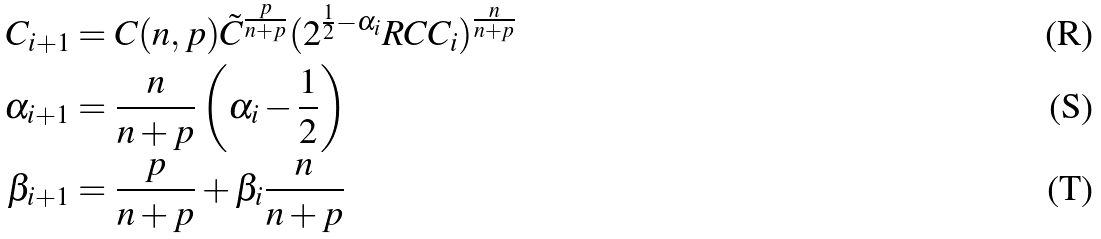Convert formula to latex. <formula><loc_0><loc_0><loc_500><loc_500>C _ { i + 1 } & = C ( n , p ) \tilde { C } ^ { \frac { p } { n + p } } ( 2 ^ { \frac { 1 } { 2 } - \alpha _ { i } } R C C _ { i } ) ^ { \frac { n } { n + p } } \\ \alpha _ { i + 1 } & = \frac { n } { n + p } \left ( \alpha _ { i } - \frac { 1 } { 2 } \right ) \\ \beta _ { i + 1 } & = \frac { p } { n + p } + \beta _ { i } \frac { n } { n + p }</formula> 